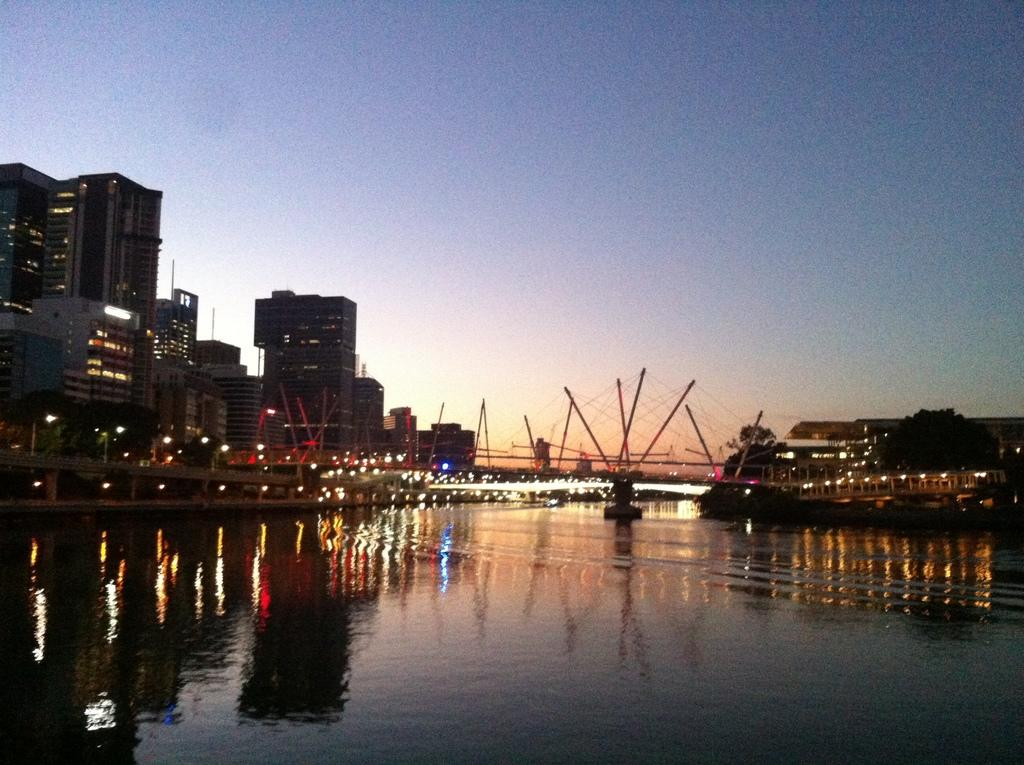What is present in the image that is not solid? There is water in the image. What type of structures can be seen in the image? There are buildings in the image. What can be seen in the distance in the image? The sky is visible in the background of the image. What type of metal is used to make the lunch in the image? There is no lunch present in the image, so it is not possible to determine what type of metal might be used. 